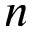Convert formula to latex. <formula><loc_0><loc_0><loc_500><loc_500>n</formula> 